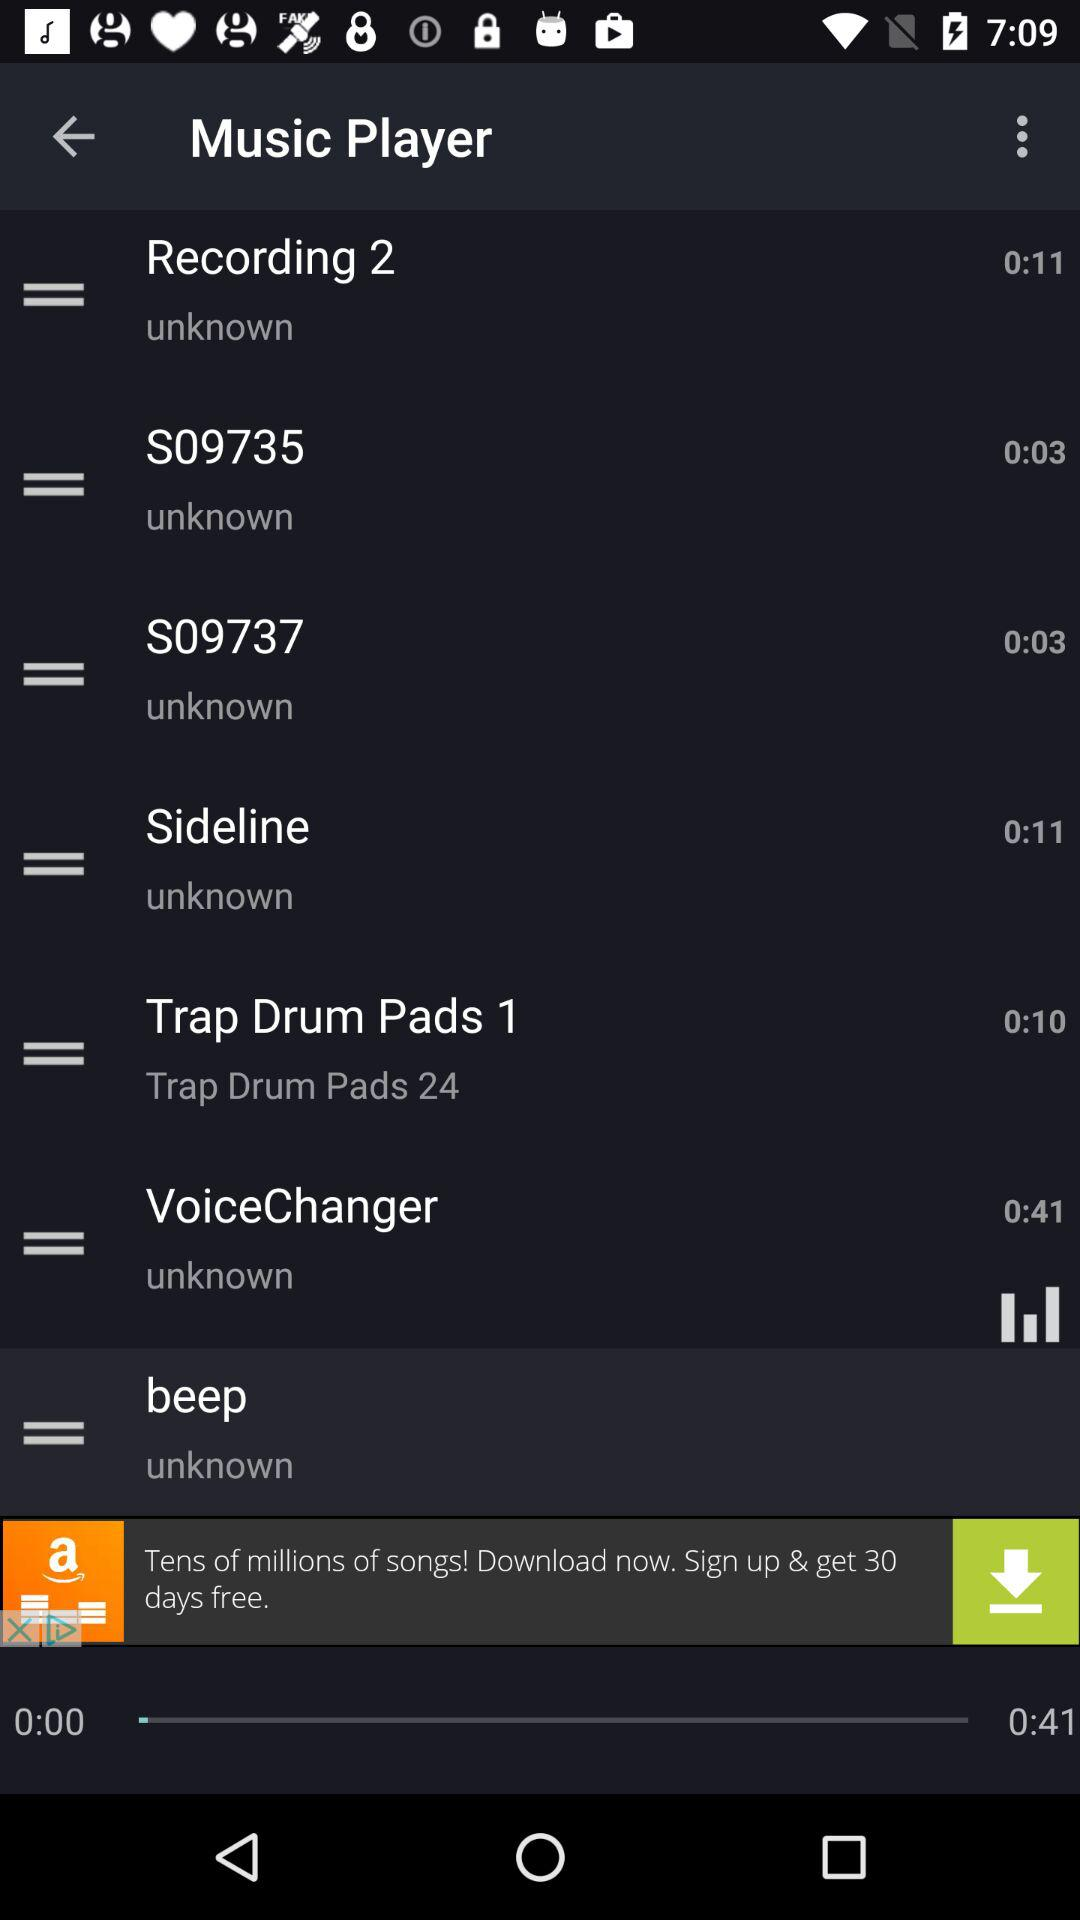What is the "Sideline" audio duration? The "Sideline" audio duration is 11 seconds. 